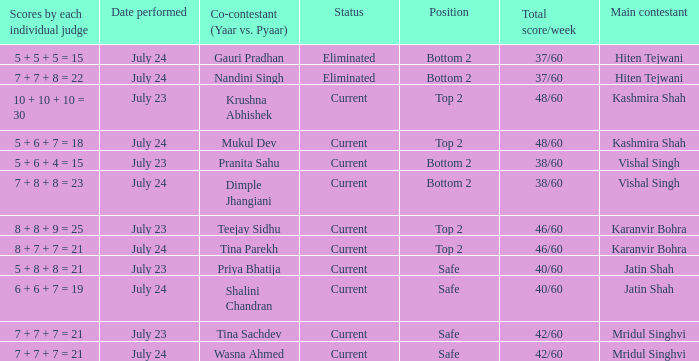Who is the main contestant with a total score/week of 42/60 and a co-contestant (Yaar vs. Pyaa) of Tina Sachdev? Mridul Singhvi. Give me the full table as a dictionary. {'header': ['Scores by each individual judge', 'Date performed', 'Co-contestant (Yaar vs. Pyaar)', 'Status', 'Position', 'Total score/week', 'Main contestant'], 'rows': [['5 + 5 + 5 = 15', 'July 24', 'Gauri Pradhan', 'Eliminated', 'Bottom 2', '37/60', 'Hiten Tejwani'], ['7 + 7 + 8 = 22', 'July 24', 'Nandini Singh', 'Eliminated', 'Bottom 2', '37/60', 'Hiten Tejwani'], ['10 + 10 + 10 = 30', 'July 23', 'Krushna Abhishek', 'Current', 'Top 2', '48/60', 'Kashmira Shah'], ['5 + 6 + 7 = 18', 'July 24', 'Mukul Dev', 'Current', 'Top 2', '48/60', 'Kashmira Shah'], ['5 + 6 + 4 = 15', 'July 23', 'Pranita Sahu', 'Current', 'Bottom 2', '38/60', 'Vishal Singh'], ['7 + 8 + 8 = 23', 'July 24', 'Dimple Jhangiani', 'Current', 'Bottom 2', '38/60', 'Vishal Singh'], ['8 + 8 + 9 = 25', 'July 23', 'Teejay Sidhu', 'Current', 'Top 2', '46/60', 'Karanvir Bohra'], ['8 + 7 + 7 = 21', 'July 24', 'Tina Parekh', 'Current', 'Top 2', '46/60', 'Karanvir Bohra'], ['5 + 8 + 8 = 21', 'July 23', 'Priya Bhatija', 'Current', 'Safe', '40/60', 'Jatin Shah'], ['6 + 6 + 7 = 19', 'July 24', 'Shalini Chandran', 'Current', 'Safe', '40/60', 'Jatin Shah'], ['7 + 7 + 7 = 21', 'July 23', 'Tina Sachdev', 'Current', 'Safe', '42/60', 'Mridul Singhvi'], ['7 + 7 + 7 = 21', 'July 24', 'Wasna Ahmed', 'Current', 'Safe', '42/60', 'Mridul Singhvi']]} 